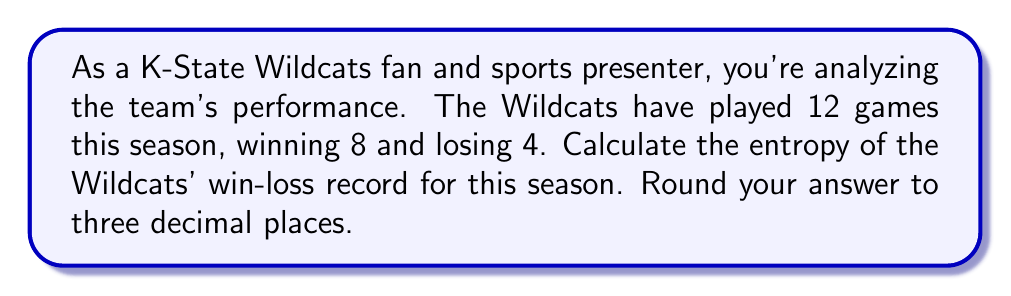Could you help me with this problem? To calculate the entropy of the K-State Wildcats' win-loss record, we'll use the formula for Shannon entropy:

$$H = -\sum_{i=1}^{n} p_i \log_2(p_i)$$

Where:
- $H$ is the entropy
- $p_i$ is the probability of each outcome
- $n$ is the number of possible outcomes (in this case, 2: win or loss)

Step 1: Calculate the probabilities
- Probability of a win: $p_{win} = \frac{8}{12} = \frac{2}{3}$
- Probability of a loss: $p_{loss} = \frac{4}{12} = \frac{1}{3}$

Step 2: Apply the entropy formula
$$\begin{align*}
H &= -[p_{win} \log_2(p_{win}) + p_{loss} \log_2(p_{loss})] \\
&= -[\frac{2}{3} \log_2(\frac{2}{3}) + \frac{1}{3} \log_2(\frac{1}{3})]
\end{align*}$$

Step 3: Calculate the logarithms
$$\begin{align*}
H &= -[\frac{2}{3} \cdot (-0.5850) + \frac{1}{3} \cdot (-1.5850)] \\
&= -[-0.3900 - 0.5283]
\end{align*}$$

Step 4: Solve the equation
$$\begin{align*}
H &= 0.9183 \text{ bits}
\end{align*}$$

Step 5: Round to three decimal places
$$H \approx 0.918 \text{ bits}$$

This entropy value indicates the average amount of information contained in each game outcome for the K-State Wildcats' season.
Answer: $0.918$ bits 